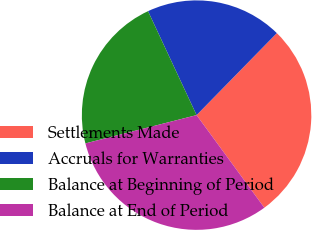<chart> <loc_0><loc_0><loc_500><loc_500><pie_chart><fcel>Settlements Made<fcel>Accruals for Warranties<fcel>Balance at Beginning of Period<fcel>Balance at End of Period<nl><fcel>27.62%<fcel>19.28%<fcel>22.01%<fcel>31.08%<nl></chart> 